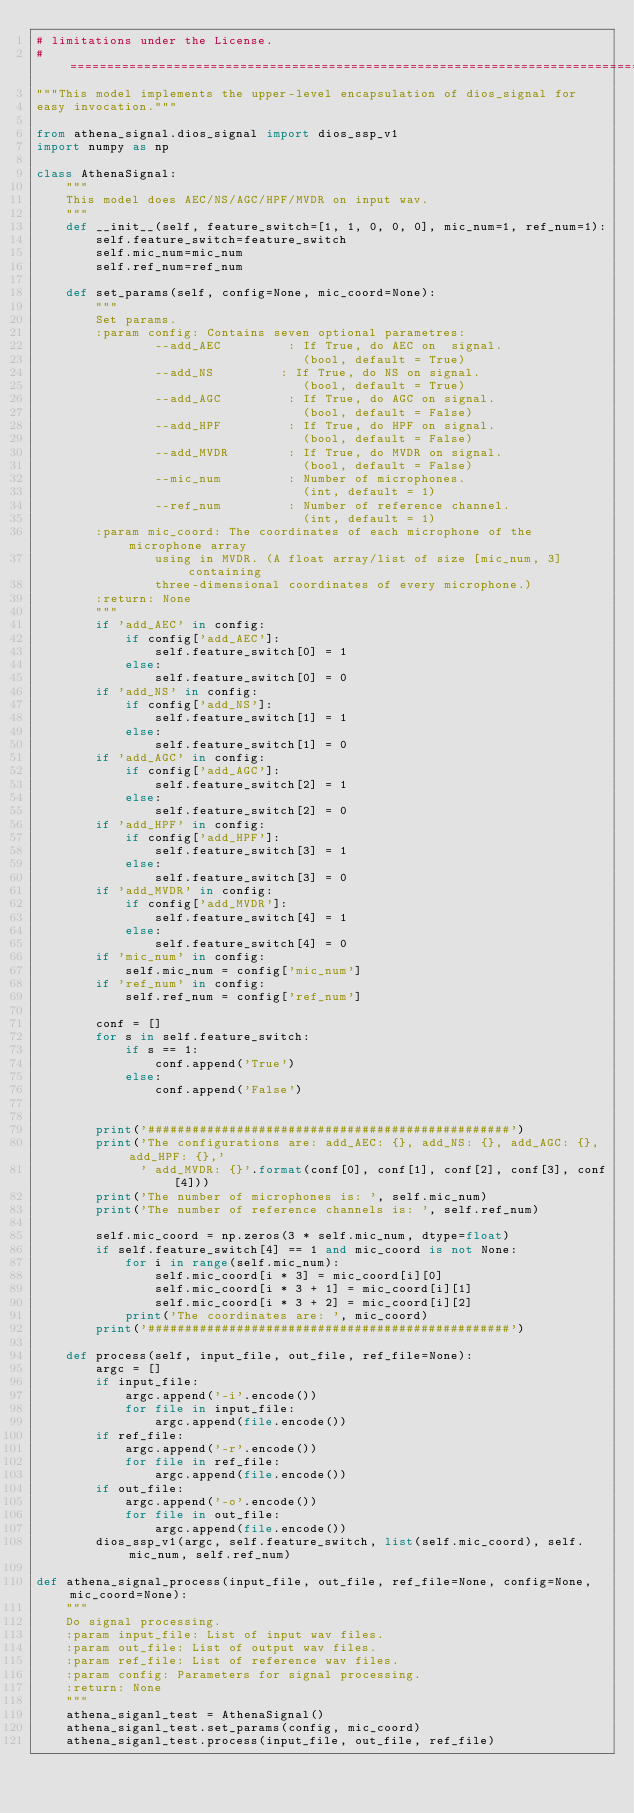Convert code to text. <code><loc_0><loc_0><loc_500><loc_500><_Python_># limitations under the License.
# ==============================================================================*/
"""This model implements the upper-level encapsulation of dios_signal for
easy invocation."""

from athena_signal.dios_signal import dios_ssp_v1
import numpy as np

class AthenaSignal:
    """
    This model does AEC/NS/AGC/HPF/MVDR on input wav.
    """
    def __init__(self, feature_switch=[1, 1, 0, 0, 0], mic_num=1, ref_num=1):
        self.feature_switch=feature_switch
        self.mic_num=mic_num
        self.ref_num=ref_num

    def set_params(self, config=None, mic_coord=None):
        """
        Set params.
        :param config: Contains seven optional parametres:
                --add_AEC         : If True, do AEC on  signal.
                                    (bool, default = True)
                --add_NS         : If True, do NS on signal.
                                    (bool, default = True)
                --add_AGC         : If True, do AGC on signal.
                                    (bool, default = False)
                --add_HPF         : If True, do HPF on signal.
                                    (bool, default = False)
                --add_MVDR        : If True, do MVDR on signal.
                                    (bool, default = False)
                --mic_num         : Number of microphones.
                                    (int, default = 1)
                --ref_num         : Number of reference channel.
                                    (int, default = 1)
        :param mic_coord: The coordinates of each microphone of the microphone array
                using in MVDR. (A float array/list of size [mic_num, 3] containing
                three-dimensional coordinates of every microphone.)
        :return: None
        """
        if 'add_AEC' in config:
            if config['add_AEC']:
                self.feature_switch[0] = 1
            else:
                self.feature_switch[0] = 0
        if 'add_NS' in config:
            if config['add_NS']:
                self.feature_switch[1] = 1
            else:
                self.feature_switch[1] = 0
        if 'add_AGC' in config:
            if config['add_AGC']:
                self.feature_switch[2] = 1
            else:
                self.feature_switch[2] = 0
        if 'add_HPF' in config:
            if config['add_HPF']:
                self.feature_switch[3] = 1
            else:
                self.feature_switch[3] = 0
        if 'add_MVDR' in config:
            if config['add_MVDR']:
                self.feature_switch[4] = 1
            else:
                self.feature_switch[4] = 0
        if 'mic_num' in config:
            self.mic_num = config['mic_num']
        if 'ref_num' in config:
            self.ref_num = config['ref_num']

        conf = []
        for s in self.feature_switch:
            if s == 1:
                conf.append('True')
            else:
                conf.append('False')


        print('#################################################')
        print('The configurations are: add_AEC: {}, add_NS: {}, add_AGC: {}, add_HPF: {},'
              ' add_MVDR: {}'.format(conf[0], conf[1], conf[2], conf[3], conf[4]))
        print('The number of microphones is: ', self.mic_num)
        print('The number of reference channels is: ', self.ref_num)

        self.mic_coord = np.zeros(3 * self.mic_num, dtype=float)
        if self.feature_switch[4] == 1 and mic_coord is not None:
            for i in range(self.mic_num):
                self.mic_coord[i * 3] = mic_coord[i][0]
                self.mic_coord[i * 3 + 1] = mic_coord[i][1]
                self.mic_coord[i * 3 + 2] = mic_coord[i][2]
            print('The coordinates are: ', mic_coord)
        print('#################################################')

    def process(self, input_file, out_file, ref_file=None):
        argc = []
        if input_file:
            argc.append('-i'.encode())
            for file in input_file:
                argc.append(file.encode())
        if ref_file:
            argc.append('-r'.encode())
            for file in ref_file:
                argc.append(file.encode())
        if out_file:
            argc.append('-o'.encode())
            for file in out_file:
                argc.append(file.encode())
        dios_ssp_v1(argc, self.feature_switch, list(self.mic_coord), self.mic_num, self.ref_num)

def athena_signal_process(input_file, out_file, ref_file=None, config=None, mic_coord=None):
    """
    Do signal processing.
    :param input_file: List of input wav files.
    :param out_file: List of output wav files.
    :param ref_file: List of reference wav files.
    :param config: Parameters for signal processing.
    :return: None
    """
    athena_siganl_test = AthenaSignal()
    athena_siganl_test.set_params(config, mic_coord)
    athena_siganl_test.process(input_file, out_file, ref_file)</code> 